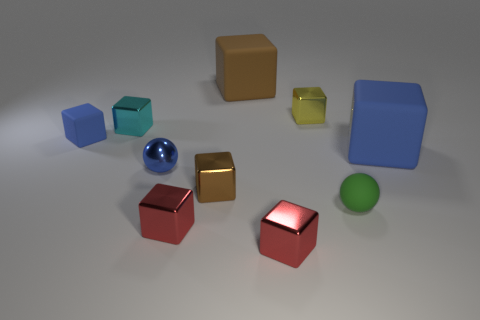Does the small shiny sphere have the same color as the small matte cube?
Offer a very short reply. Yes. What color is the tiny metal object that is both behind the small brown metallic thing and on the right side of the small blue shiny thing?
Give a very brief answer. Yellow. There is a small brown shiny object; are there any blue balls on the left side of it?
Provide a short and direct response. Yes. There is a large block on the right side of the brown rubber thing; how many cyan blocks are behind it?
Your answer should be compact. 1. The blue object that is the same material as the tiny blue block is what size?
Ensure brevity in your answer.  Large. How big is the yellow cube?
Provide a succinct answer. Small. Does the tiny yellow object have the same material as the cyan cube?
Give a very brief answer. Yes. How many blocks are either shiny things or small purple rubber objects?
Your response must be concise. 5. What color is the small matte object to the right of the blue block that is behind the large blue rubber cube?
Your answer should be compact. Green. There is a ball that is the same color as the tiny rubber block; what size is it?
Ensure brevity in your answer.  Small. 